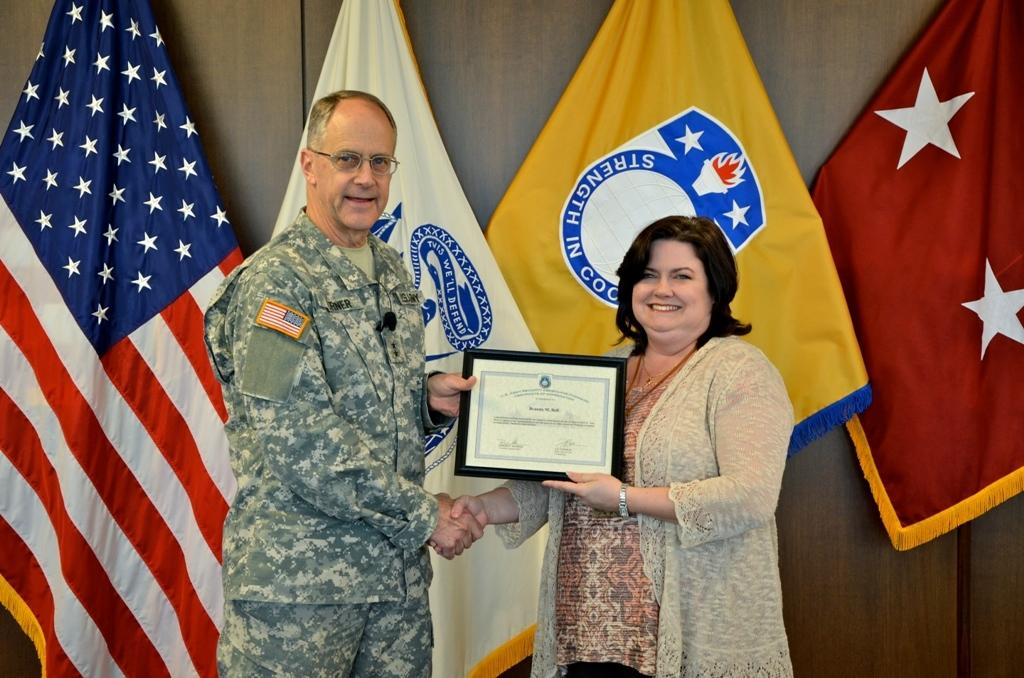How many people are in the image? There are two persons in the image. What are the persons doing in the image? The persons are standing and holding a certificate. What can be seen in the background of the image? There are flags and a wooden wall visible in the background of the image. What type of tooth is visible in the image? There is no tooth present in the image. Can you tell me how the porter is helping the persons in the image? There is no porter present in the image, so it is not possible to determine how they might be helping. 